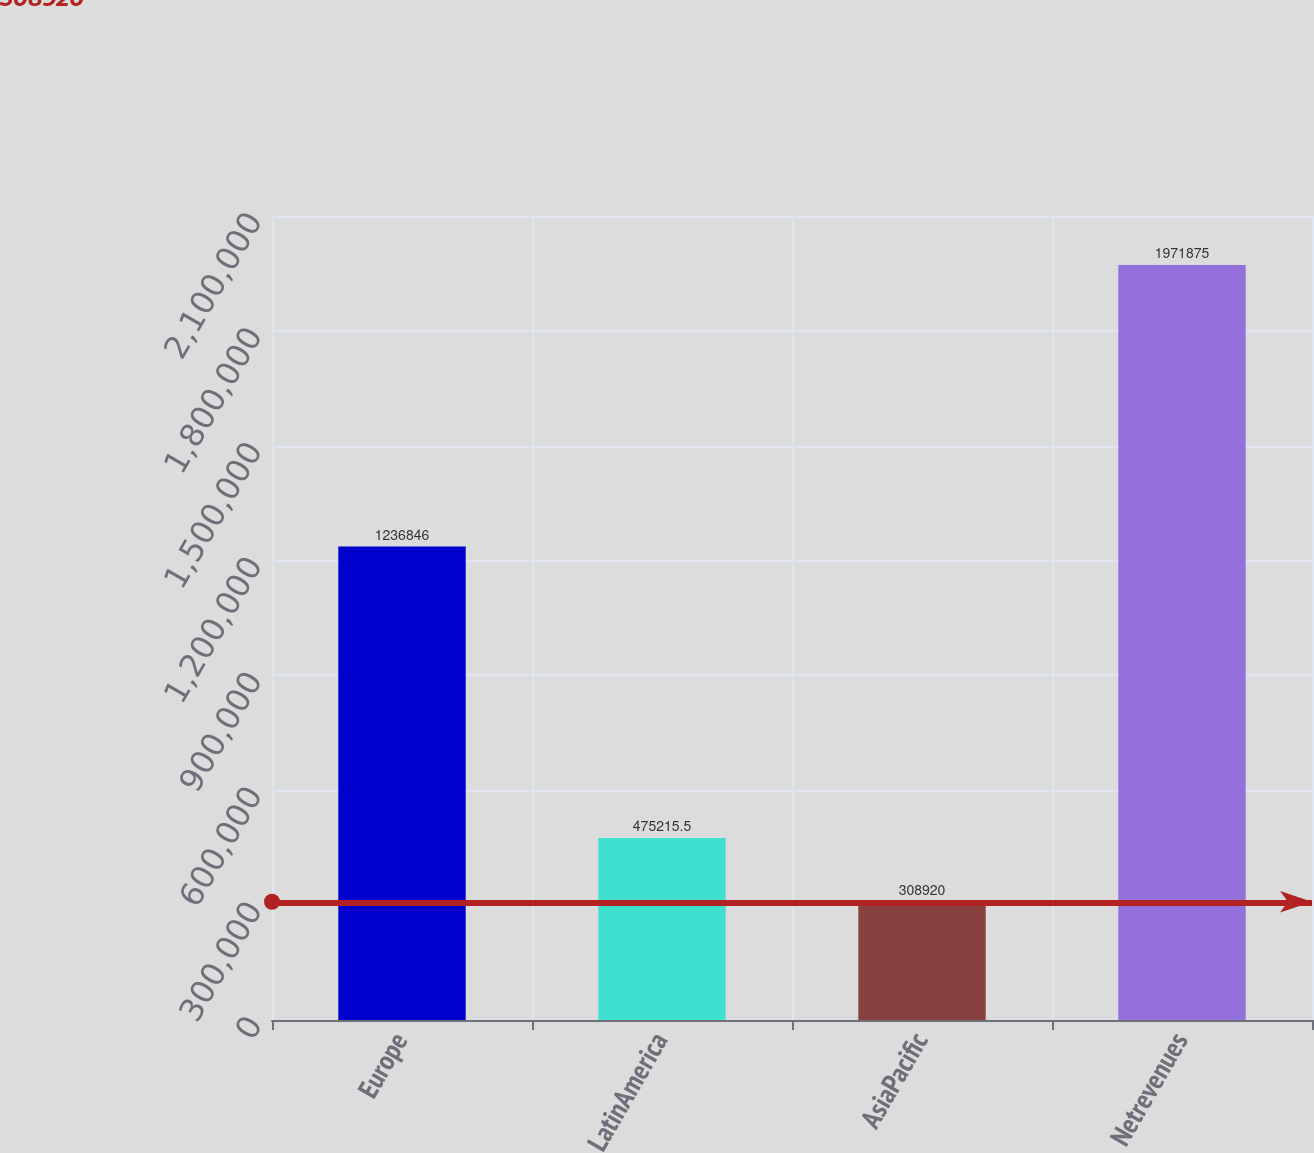Convert chart. <chart><loc_0><loc_0><loc_500><loc_500><bar_chart><fcel>Europe<fcel>LatinAmerica<fcel>AsiaPacific<fcel>Netrevenues<nl><fcel>1.23685e+06<fcel>475216<fcel>308920<fcel>1.97188e+06<nl></chart> 